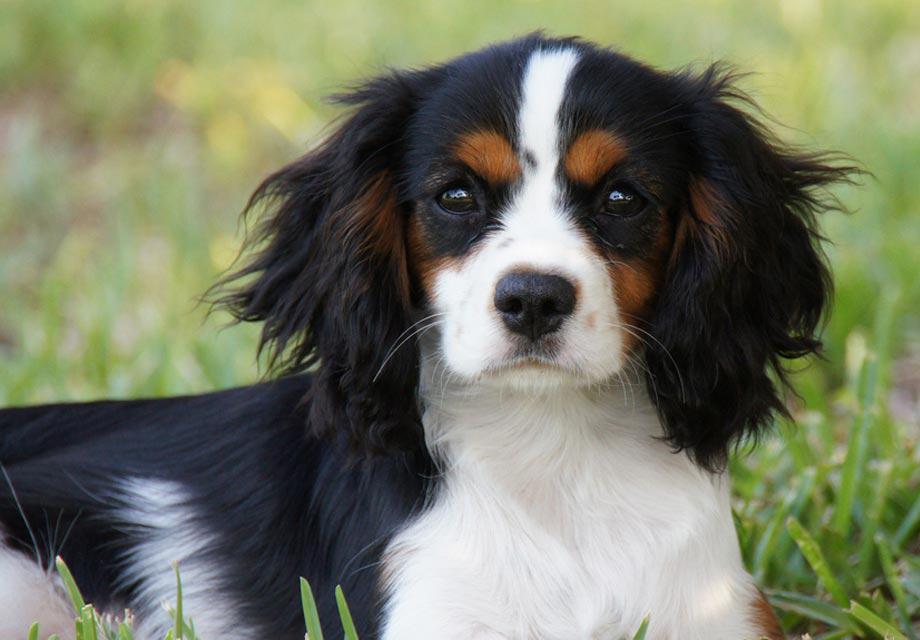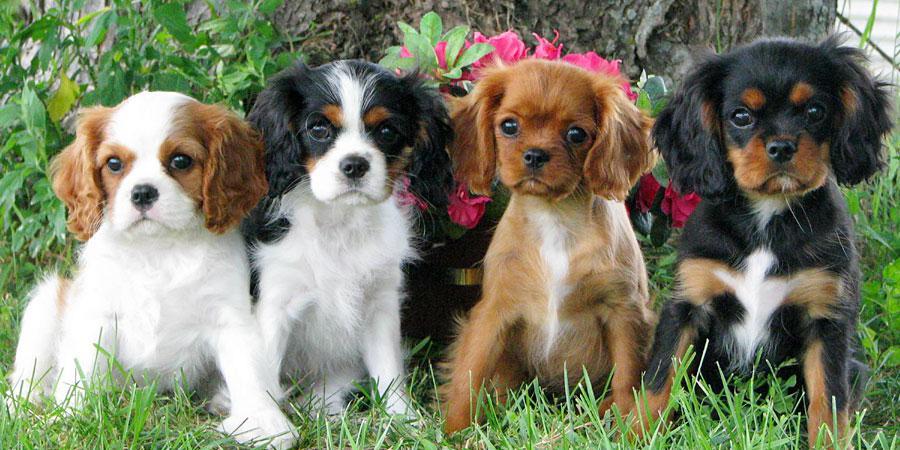The first image is the image on the left, the second image is the image on the right. For the images shown, is this caption "The right image contains more dogs than the left image." true? Answer yes or no. Yes. The first image is the image on the left, the second image is the image on the right. Analyze the images presented: Is the assertion "There is a dog resting in the grass" valid? Answer yes or no. Yes. 